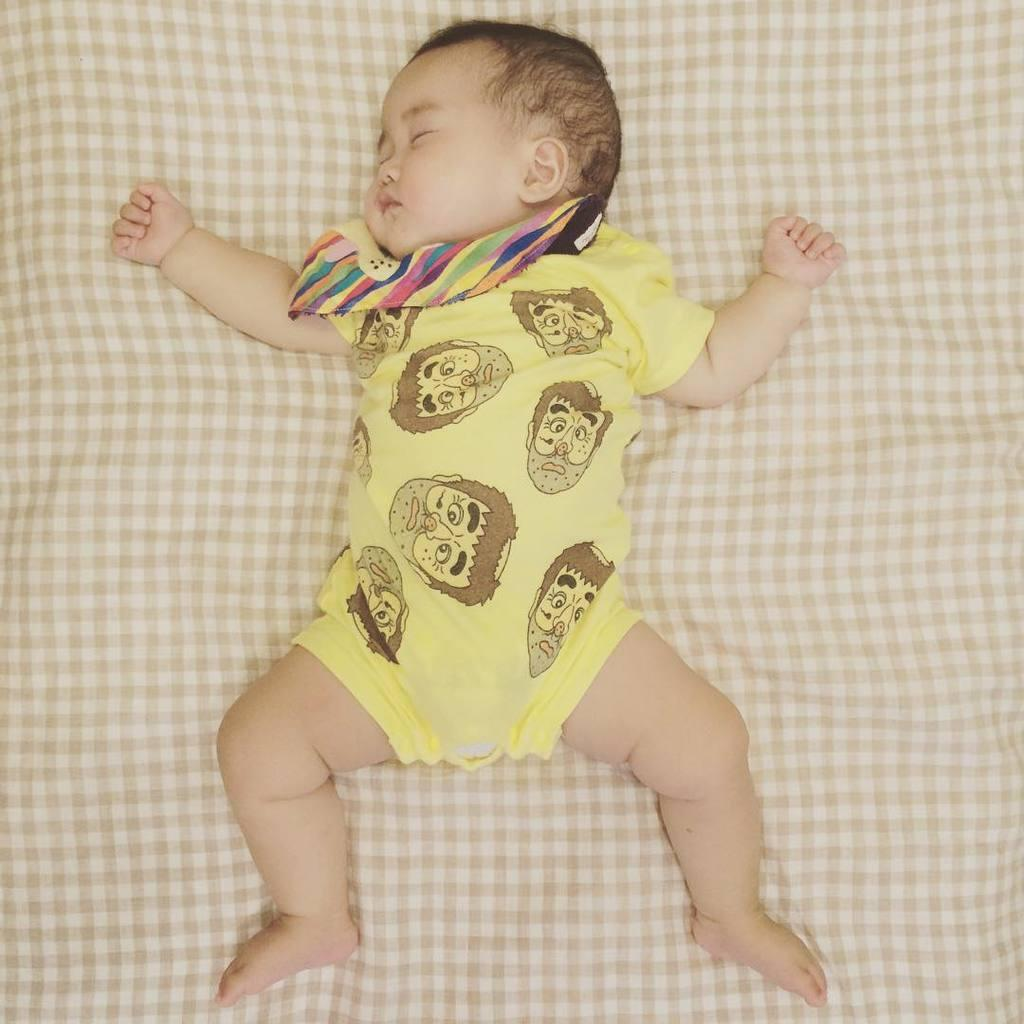What is the main subject of the image? There is a baby in the image. What is the baby doing in the image? The baby is sleeping. What is the baby lying on in the image? The baby is on a cloth. Can you see any ladybugs crawling on the baby in the image? No, there are no ladybugs present in the image. 